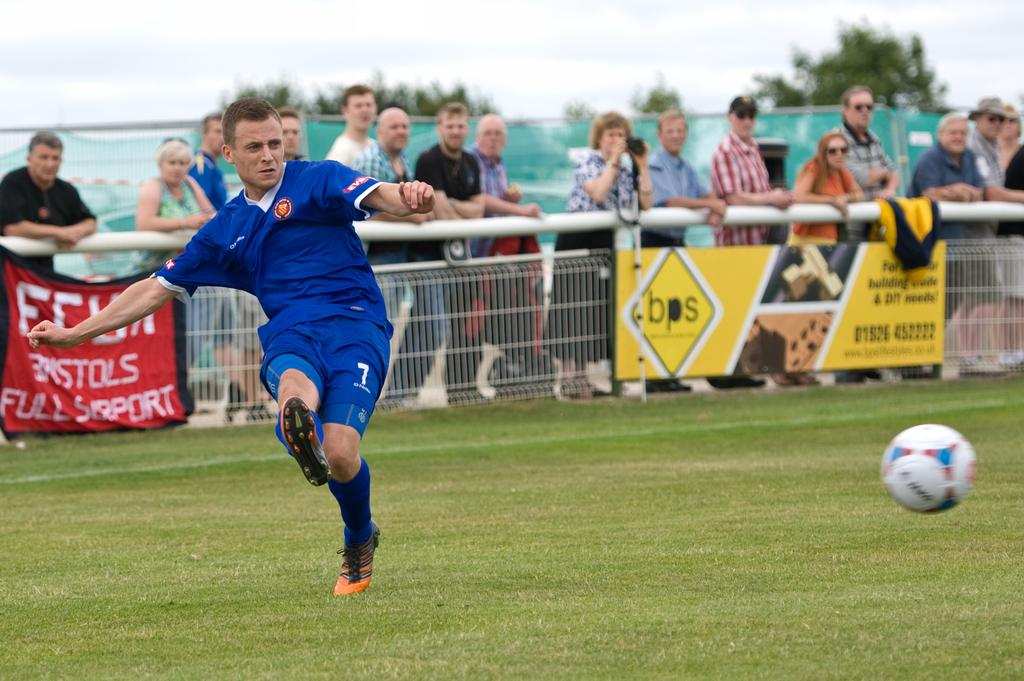Provide a one-sentence caption for the provided image. A soccer game is in progress on a field with a bps advertisement on its fence. 